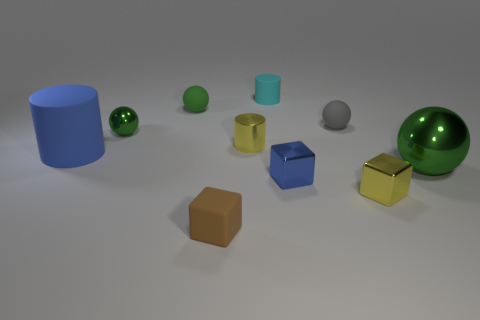Is there a pattern to how the objects are arranged in this image? The objects seem to be arranged from left to right in no clear pattern, varying in color, shape, and size. The arrangement appears random, without a discernible sequence or symmetry. Do any of the objects seem to have a reflective surface? Yes, the green metallic ball and the yellow cube appear to have reflective surfaces, which distinguish them from the other objects with matte finishes. 